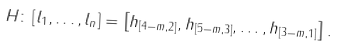Convert formula to latex. <formula><loc_0><loc_0><loc_500><loc_500>H \colon \left [ l _ { 1 } , \dots , l _ { n } \right ] = \left [ h _ { [ 4 - m , 2 ] } , h _ { [ 5 - m , 3 ] } , \dots , h _ { [ 3 - m , 1 ] } \right ] .</formula> 